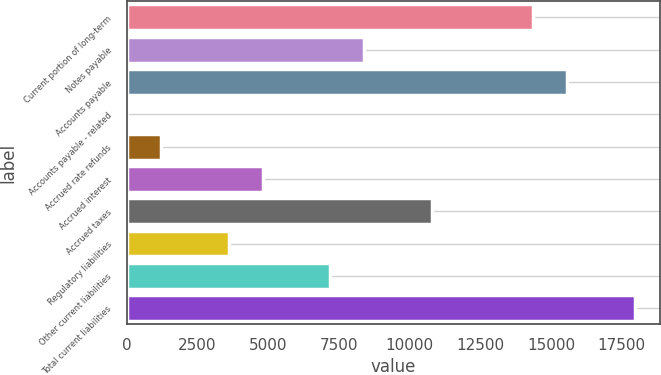Convert chart. <chart><loc_0><loc_0><loc_500><loc_500><bar_chart><fcel>Current portion of long-term<fcel>Notes payable<fcel>Accounts payable<fcel>Accounts payable - related<fcel>Accrued rate refunds<fcel>Accrued interest<fcel>Accrued taxes<fcel>Regulatory liabilities<fcel>Other current liabilities<fcel>Total current liabilities<nl><fcel>14374<fcel>8389<fcel>15571<fcel>10<fcel>1207<fcel>4798<fcel>10783<fcel>3601<fcel>7192<fcel>17965<nl></chart> 